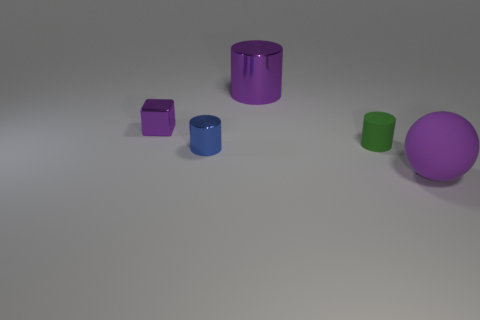What number of objects are small blue objects or small gray metallic objects?
Your response must be concise. 1. What number of things are both to the left of the large purple ball and right of the small blue metal cylinder?
Your response must be concise. 2. Is the number of matte spheres that are behind the small green rubber cylinder less than the number of small green rubber cylinders?
Make the answer very short. Yes. There is a green rubber thing that is the same size as the blue metal cylinder; what shape is it?
Offer a terse response. Cylinder. How many other things are the same color as the big matte object?
Provide a succinct answer. 2. Does the purple ball have the same size as the green object?
Provide a short and direct response. No. How many objects are large purple things or purple things that are in front of the big purple metallic cylinder?
Offer a very short reply. 3. Is the number of large purple metal objects that are on the right side of the purple matte object less than the number of purple shiny cylinders behind the small matte object?
Give a very brief answer. Yes. What number of other things are made of the same material as the purple ball?
Your answer should be very brief. 1. There is a large thing that is in front of the small green matte object; is its color the same as the small cube?
Your answer should be compact. Yes. 